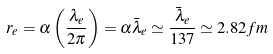Convert formula to latex. <formula><loc_0><loc_0><loc_500><loc_500>r _ { e } = \alpha \left ( { \frac { \lambda _ { e } } { 2 \pi } } \right ) = \alpha { \bar { \lambda } } _ { e } \simeq { \frac { { \bar { \lambda } } _ { e } } { 1 3 7 } } \simeq 2 . 8 2 { f m }</formula> 